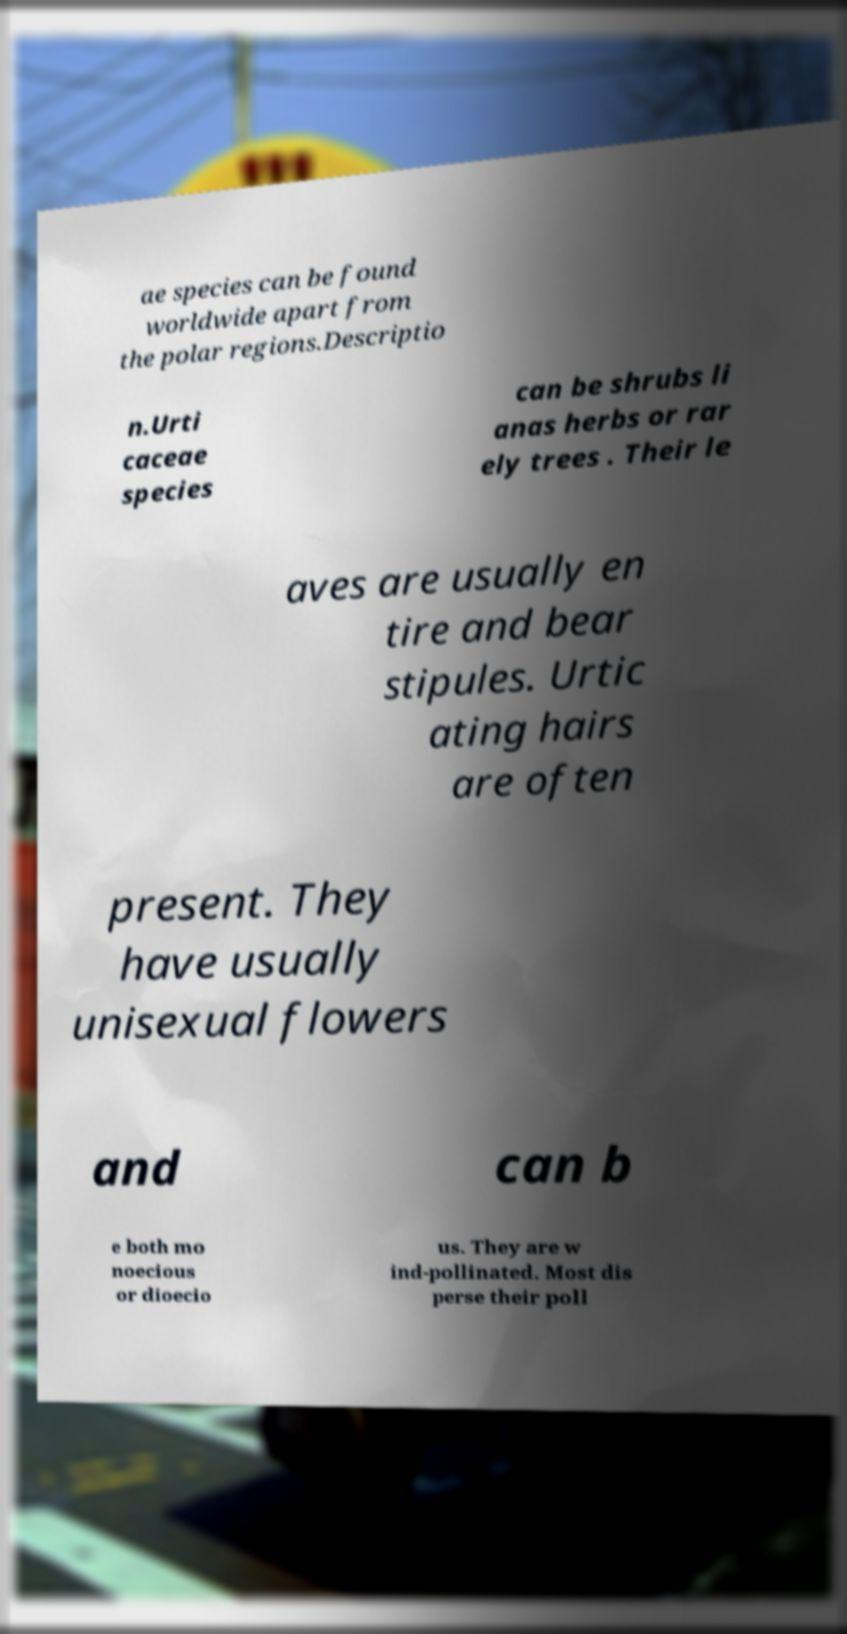Could you extract and type out the text from this image? ae species can be found worldwide apart from the polar regions.Descriptio n.Urti caceae species can be shrubs li anas herbs or rar ely trees . Their le aves are usually en tire and bear stipules. Urtic ating hairs are often present. They have usually unisexual flowers and can b e both mo noecious or dioecio us. They are w ind-pollinated. Most dis perse their poll 